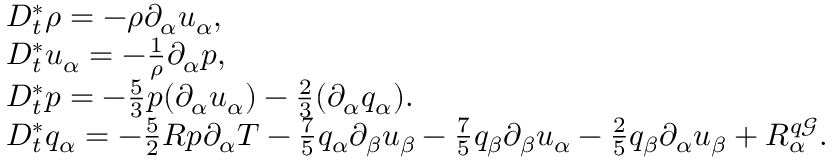<formula> <loc_0><loc_0><loc_500><loc_500>\begin{array} { r l } & { D _ { t } ^ { * } \rho = - \rho \partial _ { \alpha } u _ { \alpha } , } \\ & { D _ { t } ^ { * } u _ { \alpha } = - \frac { 1 } { \rho } \partial _ { \alpha } p , } \\ & { D _ { t } ^ { * } p = - \frac { 5 } { 3 } p ( \partial _ { \alpha } u _ { \alpha } ) - \frac { 2 } { 3 } ( \partial _ { \alpha } q _ { \alpha } ) . } \\ & { D _ { t } ^ { * } q _ { \alpha } = - \frac { 5 } { 2 } R p \partial _ { \alpha } T - \frac { 7 } { 5 } q _ { \alpha } \partial _ { \beta } u _ { \beta } - \frac { 7 } { 5 } q _ { \beta } \partial _ { \beta } u _ { \alpha } - \frac { 2 } { 5 } q _ { \beta } \partial _ { \alpha } u _ { \beta } + R _ { \alpha } ^ { q \mathcal { G } } . } \end{array}</formula> 